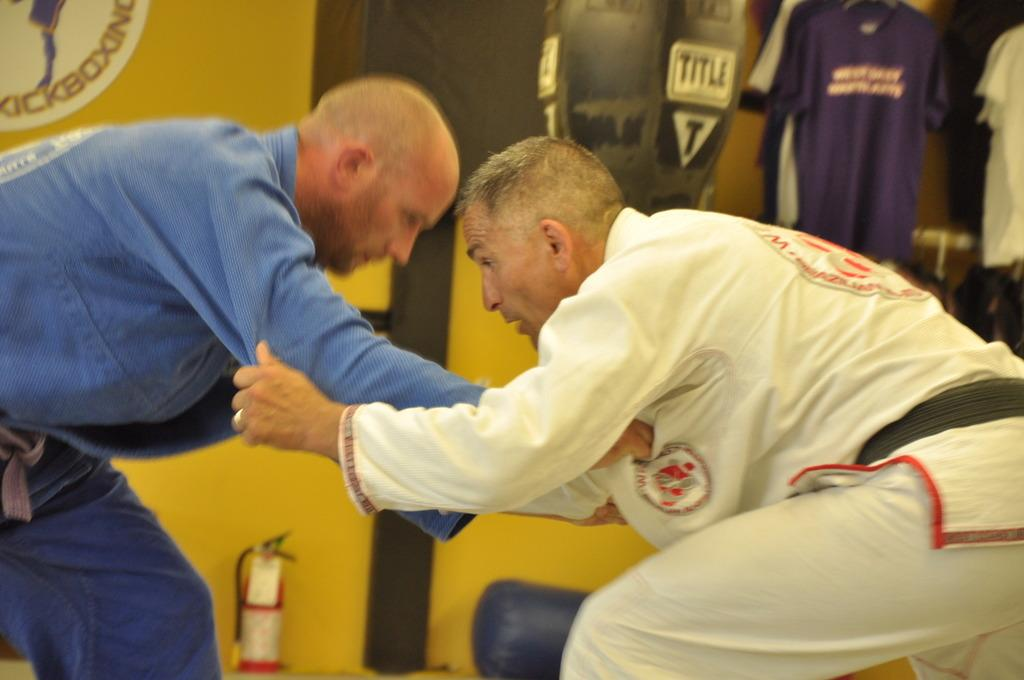How many people are in the image? There are two men in the image. What can be seen in the background of the image? There are clothes hanging in the background. What color is the wall that is visible in the image? There is a yellow color wall in the image. What type of produce is being harvested by the men in the image? There is no produce visible in the image, and the men are not shown harvesting anything. 